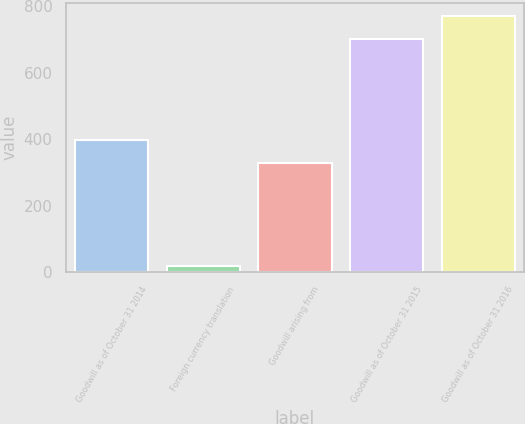Convert chart. <chart><loc_0><loc_0><loc_500><loc_500><bar_chart><fcel>Goodwill as of October 31 2014<fcel>Foreign currency translation<fcel>Goodwill arising from<fcel>Goodwill as of October 31 2015<fcel>Goodwill as of October 31 2016<nl><fcel>398.7<fcel>19<fcel>327<fcel>700<fcel>771.7<nl></chart> 